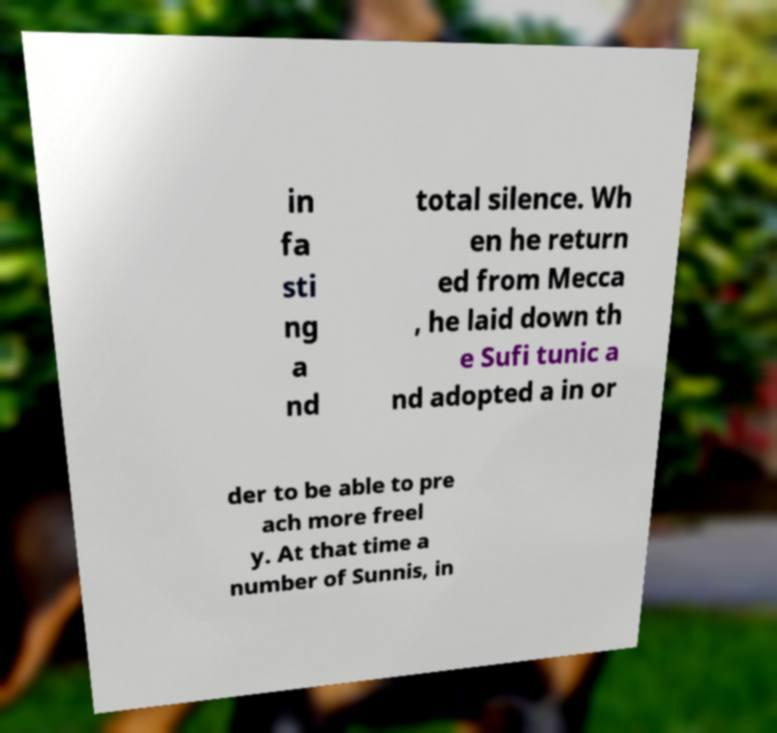Can you read and provide the text displayed in the image?This photo seems to have some interesting text. Can you extract and type it out for me? in fa sti ng a nd total silence. Wh en he return ed from Mecca , he laid down th e Sufi tunic a nd adopted a in or der to be able to pre ach more freel y. At that time a number of Sunnis, in 